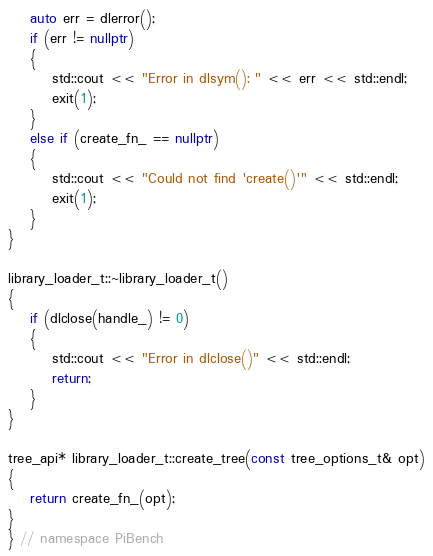Convert code to text. <code><loc_0><loc_0><loc_500><loc_500><_C++_>    auto err = dlerror();
    if (err != nullptr)
    {
        std::cout << "Error in dlsym(): " << err << std::endl;
        exit(1);
    }
    else if (create_fn_ == nullptr)
    {
        std::cout << "Could not find 'create()'" << std::endl;
        exit(1);
    }
}

library_loader_t::~library_loader_t()
{
    if (dlclose(handle_) != 0)
    {
        std::cout << "Error in dlclose()" << std::endl;
        return;
    }
}

tree_api* library_loader_t::create_tree(const tree_options_t& opt)
{
    return create_fn_(opt);
}
} // namespace PiBench</code> 